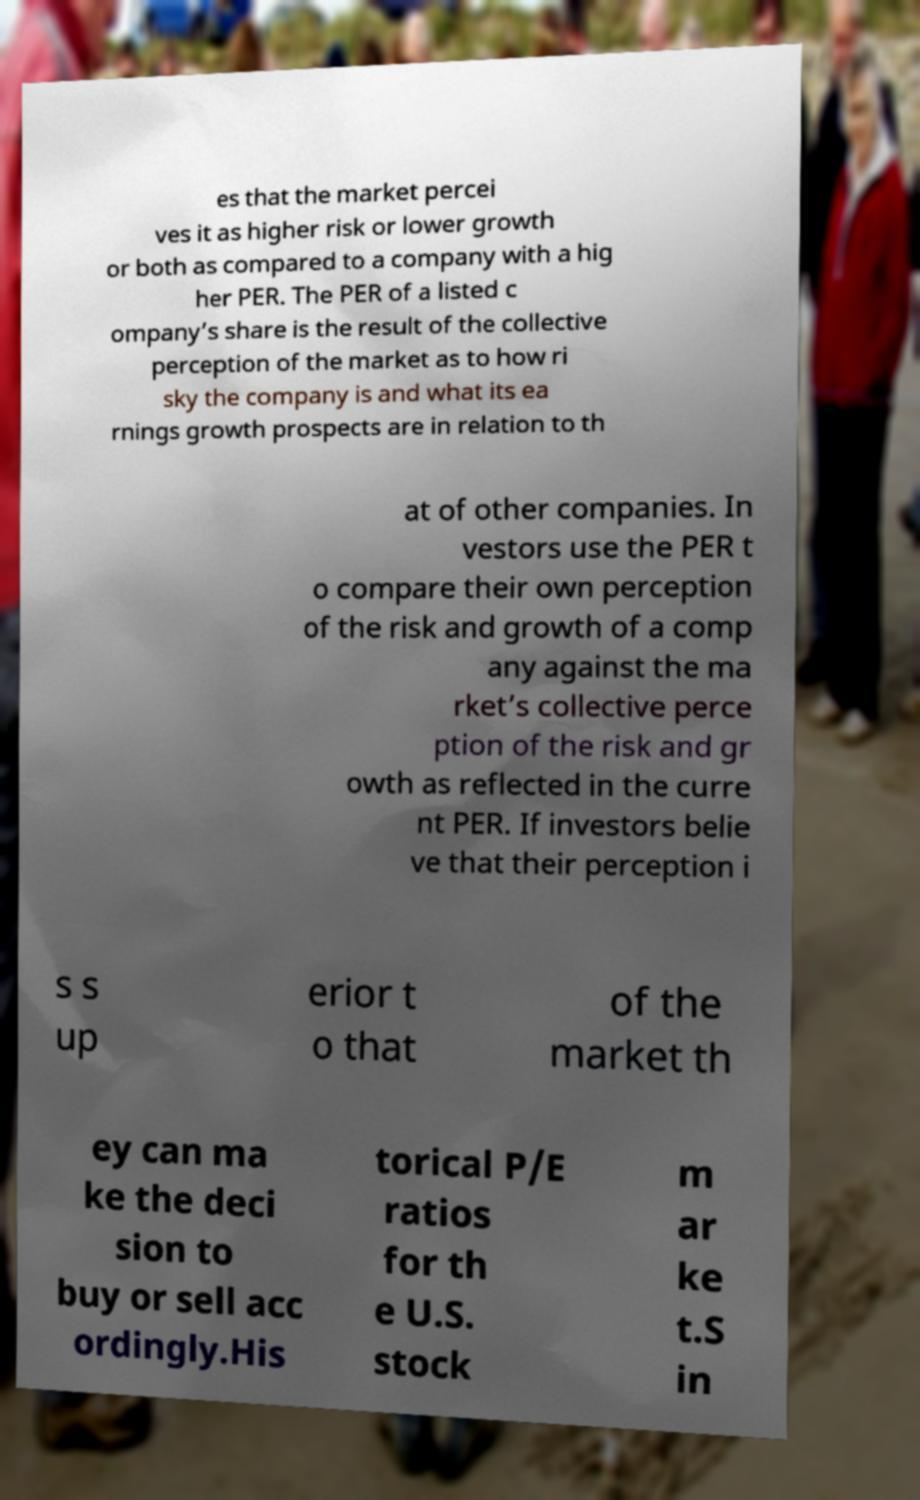For documentation purposes, I need the text within this image transcribed. Could you provide that? es that the market percei ves it as higher risk or lower growth or both as compared to a company with a hig her PER. The PER of a listed c ompany’s share is the result of the collective perception of the market as to how ri sky the company is and what its ea rnings growth prospects are in relation to th at of other companies. In vestors use the PER t o compare their own perception of the risk and growth of a comp any against the ma rket’s collective perce ption of the risk and gr owth as reflected in the curre nt PER. If investors belie ve that their perception i s s up erior t o that of the market th ey can ma ke the deci sion to buy or sell acc ordingly.His torical P/E ratios for th e U.S. stock m ar ke t.S in 